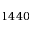Convert formula to latex. <formula><loc_0><loc_0><loc_500><loc_500>1 4 4 0</formula> 